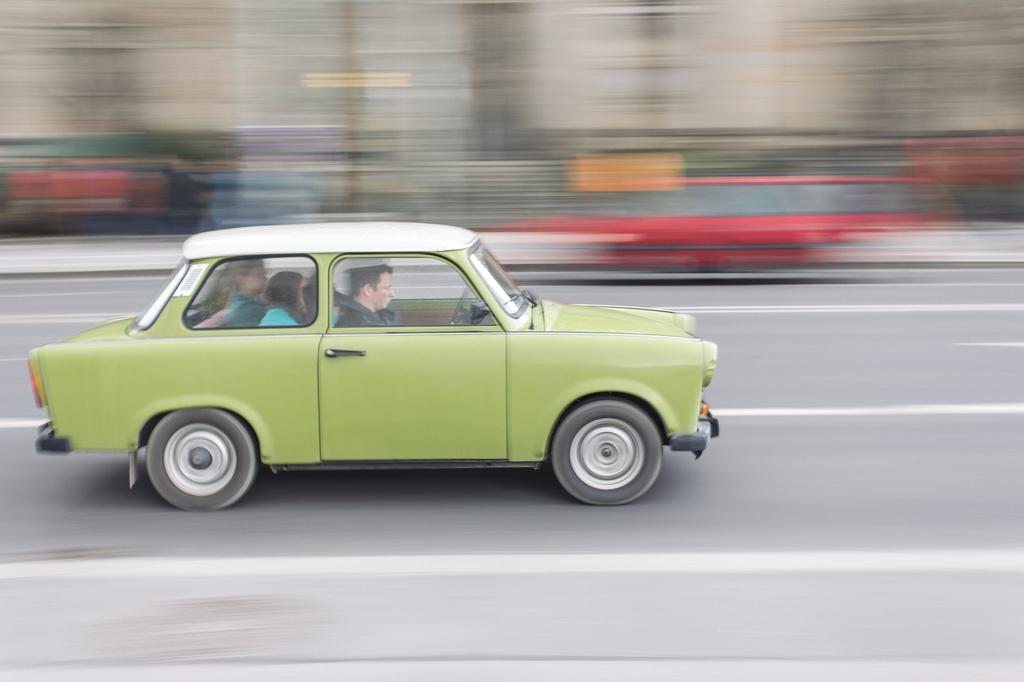In one or two sentences, can you explain what this image depicts? In front of the picture, we see three people are riding a green color car. At the bottom of the picture, we see the road. It is blurred in the background. 